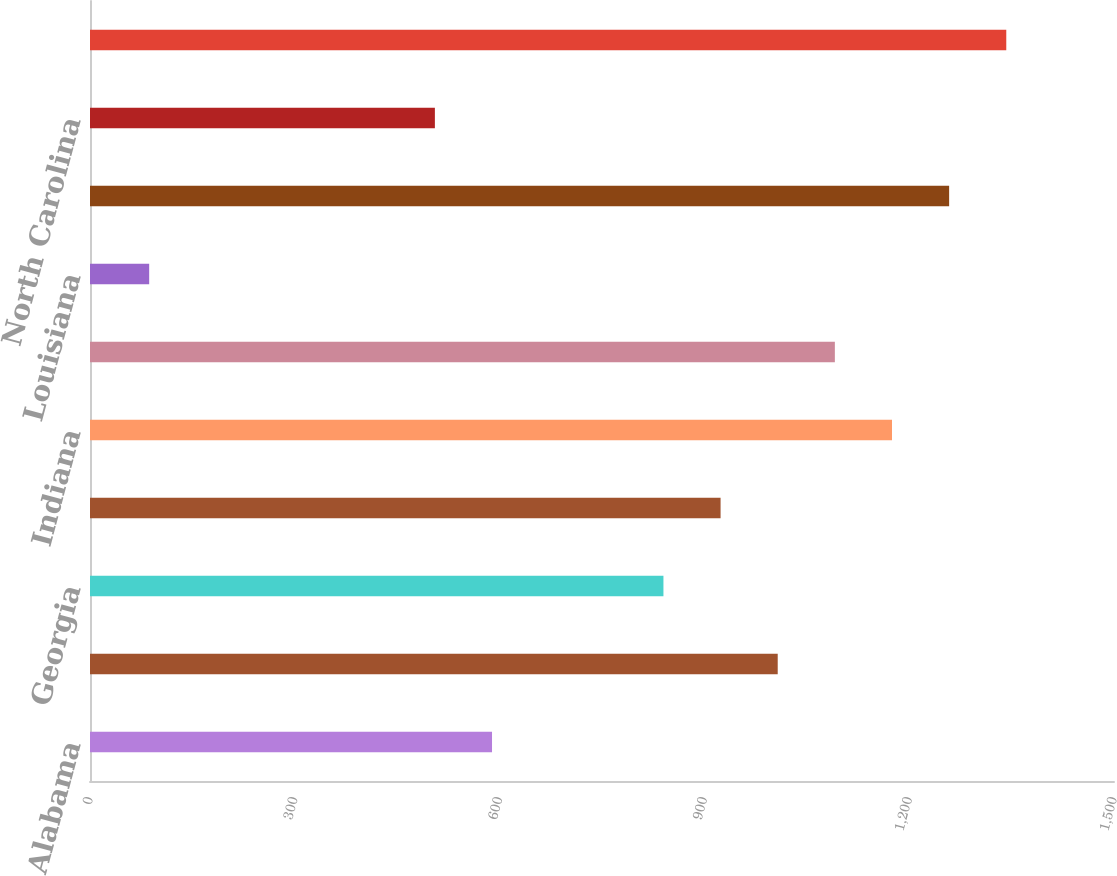Convert chart to OTSL. <chart><loc_0><loc_0><loc_500><loc_500><bar_chart><fcel>Alabama<fcel>Florida<fcel>Georgia<fcel>Illinois<fcel>Indiana<fcel>Kentucky<fcel>Louisiana<fcel>Michigan<fcel>North Carolina<fcel>Ohio<nl><fcel>588.9<fcel>1007.4<fcel>840<fcel>923.7<fcel>1174.8<fcel>1091.1<fcel>86.7<fcel>1258.5<fcel>505.2<fcel>1342.2<nl></chart> 